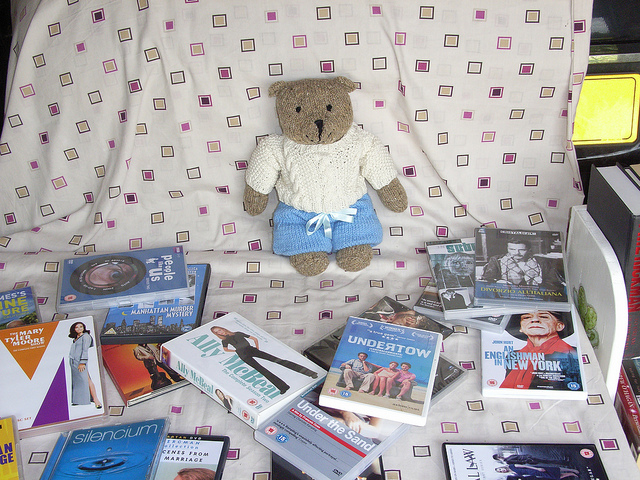Please identify all text content in this image. UNDERTOW ENGLISHMAN NEW YORK sub Sand Under Silencium MARRIAGE N C peopl Ally 